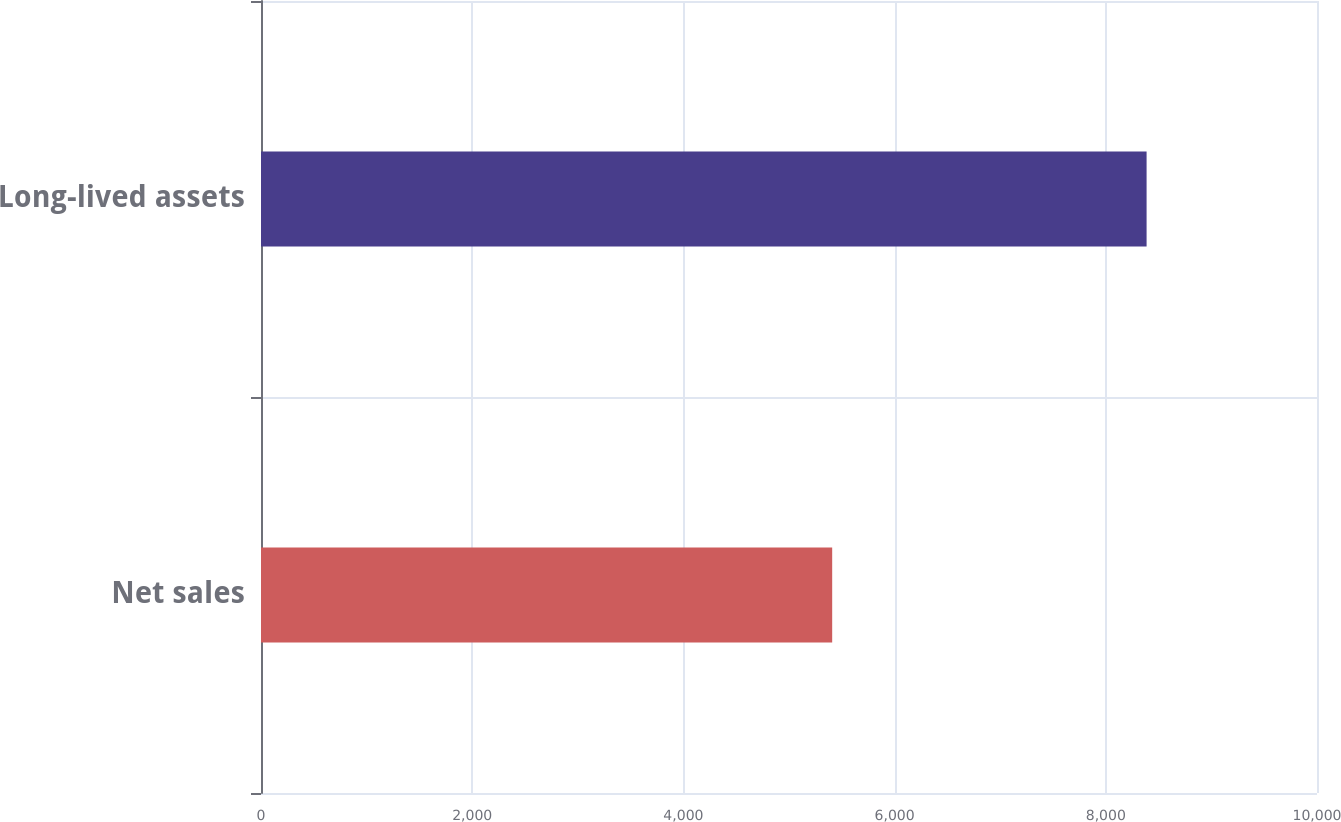Convert chart to OTSL. <chart><loc_0><loc_0><loc_500><loc_500><bar_chart><fcel>Net sales<fcel>Long-lived assets<nl><fcel>5408.9<fcel>8386.3<nl></chart> 